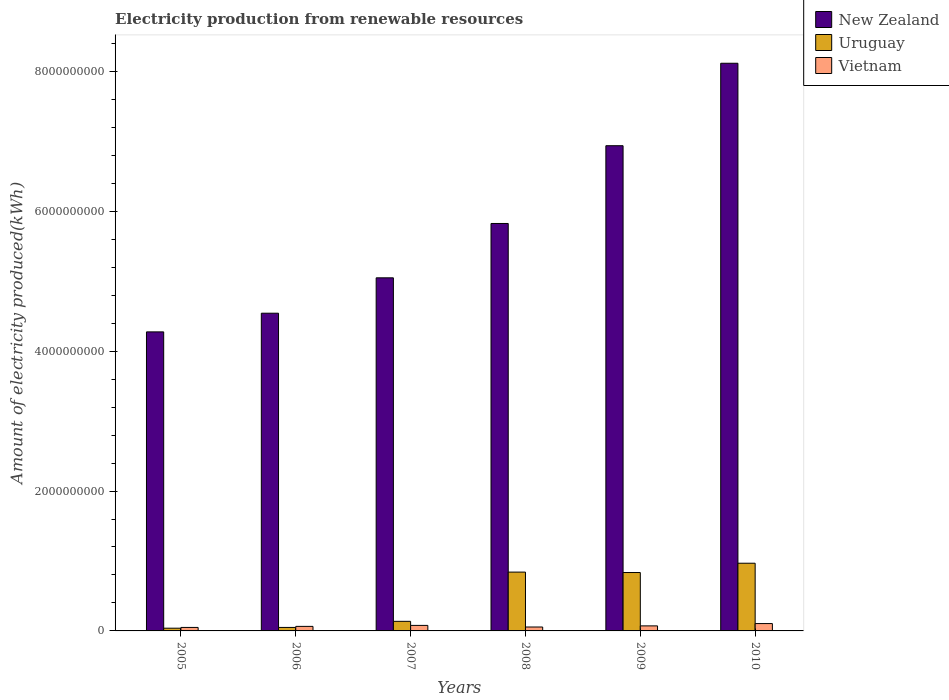How many groups of bars are there?
Make the answer very short. 6. Are the number of bars on each tick of the X-axis equal?
Keep it short and to the point. Yes. What is the label of the 2nd group of bars from the left?
Offer a very short reply. 2006. In how many cases, is the number of bars for a given year not equal to the number of legend labels?
Keep it short and to the point. 0. What is the amount of electricity produced in New Zealand in 2008?
Make the answer very short. 5.83e+09. Across all years, what is the maximum amount of electricity produced in Vietnam?
Keep it short and to the point. 1.05e+08. Across all years, what is the minimum amount of electricity produced in Uruguay?
Ensure brevity in your answer.  3.90e+07. In which year was the amount of electricity produced in New Zealand maximum?
Provide a succinct answer. 2010. In which year was the amount of electricity produced in Vietnam minimum?
Keep it short and to the point. 2005. What is the total amount of electricity produced in Uruguay in the graph?
Ensure brevity in your answer.  2.87e+09. What is the difference between the amount of electricity produced in Vietnam in 2007 and that in 2008?
Ensure brevity in your answer.  2.30e+07. What is the difference between the amount of electricity produced in Uruguay in 2008 and the amount of electricity produced in New Zealand in 2010?
Make the answer very short. -7.28e+09. What is the average amount of electricity produced in Vietnam per year?
Ensure brevity in your answer.  7.12e+07. In the year 2006, what is the difference between the amount of electricity produced in Uruguay and amount of electricity produced in New Zealand?
Keep it short and to the point. -4.49e+09. What is the ratio of the amount of electricity produced in Vietnam in 2007 to that in 2010?
Offer a terse response. 0.75. Is the difference between the amount of electricity produced in Uruguay in 2005 and 2006 greater than the difference between the amount of electricity produced in New Zealand in 2005 and 2006?
Your response must be concise. Yes. What is the difference between the highest and the second highest amount of electricity produced in New Zealand?
Provide a succinct answer. 1.18e+09. What is the difference between the highest and the lowest amount of electricity produced in Vietnam?
Give a very brief answer. 5.50e+07. In how many years, is the amount of electricity produced in New Zealand greater than the average amount of electricity produced in New Zealand taken over all years?
Your answer should be compact. 3. What does the 3rd bar from the left in 2005 represents?
Your response must be concise. Vietnam. What does the 1st bar from the right in 2009 represents?
Keep it short and to the point. Vietnam. Is it the case that in every year, the sum of the amount of electricity produced in Uruguay and amount of electricity produced in New Zealand is greater than the amount of electricity produced in Vietnam?
Provide a short and direct response. Yes. How many bars are there?
Make the answer very short. 18. How many years are there in the graph?
Give a very brief answer. 6. Are the values on the major ticks of Y-axis written in scientific E-notation?
Keep it short and to the point. No. Does the graph contain grids?
Keep it short and to the point. No. Where does the legend appear in the graph?
Ensure brevity in your answer.  Top right. How many legend labels are there?
Your answer should be compact. 3. What is the title of the graph?
Your response must be concise. Electricity production from renewable resources. Does "High income" appear as one of the legend labels in the graph?
Your answer should be very brief. No. What is the label or title of the X-axis?
Keep it short and to the point. Years. What is the label or title of the Y-axis?
Give a very brief answer. Amount of electricity produced(kWh). What is the Amount of electricity produced(kWh) in New Zealand in 2005?
Provide a short and direct response. 4.28e+09. What is the Amount of electricity produced(kWh) in Uruguay in 2005?
Make the answer very short. 3.90e+07. What is the Amount of electricity produced(kWh) in New Zealand in 2006?
Your answer should be very brief. 4.54e+09. What is the Amount of electricity produced(kWh) in Vietnam in 2006?
Give a very brief answer. 6.50e+07. What is the Amount of electricity produced(kWh) of New Zealand in 2007?
Your answer should be very brief. 5.05e+09. What is the Amount of electricity produced(kWh) of Uruguay in 2007?
Provide a succinct answer. 1.37e+08. What is the Amount of electricity produced(kWh) in Vietnam in 2007?
Your response must be concise. 7.90e+07. What is the Amount of electricity produced(kWh) in New Zealand in 2008?
Your answer should be very brief. 5.83e+09. What is the Amount of electricity produced(kWh) in Uruguay in 2008?
Provide a short and direct response. 8.41e+08. What is the Amount of electricity produced(kWh) of Vietnam in 2008?
Your response must be concise. 5.60e+07. What is the Amount of electricity produced(kWh) in New Zealand in 2009?
Offer a very short reply. 6.94e+09. What is the Amount of electricity produced(kWh) in Uruguay in 2009?
Your answer should be compact. 8.35e+08. What is the Amount of electricity produced(kWh) of Vietnam in 2009?
Provide a succinct answer. 7.20e+07. What is the Amount of electricity produced(kWh) of New Zealand in 2010?
Provide a succinct answer. 8.12e+09. What is the Amount of electricity produced(kWh) of Uruguay in 2010?
Ensure brevity in your answer.  9.68e+08. What is the Amount of electricity produced(kWh) of Vietnam in 2010?
Your answer should be compact. 1.05e+08. Across all years, what is the maximum Amount of electricity produced(kWh) of New Zealand?
Your answer should be compact. 8.12e+09. Across all years, what is the maximum Amount of electricity produced(kWh) of Uruguay?
Ensure brevity in your answer.  9.68e+08. Across all years, what is the maximum Amount of electricity produced(kWh) of Vietnam?
Offer a terse response. 1.05e+08. Across all years, what is the minimum Amount of electricity produced(kWh) of New Zealand?
Keep it short and to the point. 4.28e+09. Across all years, what is the minimum Amount of electricity produced(kWh) of Uruguay?
Provide a short and direct response. 3.90e+07. What is the total Amount of electricity produced(kWh) of New Zealand in the graph?
Offer a very short reply. 3.47e+1. What is the total Amount of electricity produced(kWh) of Uruguay in the graph?
Give a very brief answer. 2.87e+09. What is the total Amount of electricity produced(kWh) in Vietnam in the graph?
Offer a very short reply. 4.27e+08. What is the difference between the Amount of electricity produced(kWh) of New Zealand in 2005 and that in 2006?
Your answer should be compact. -2.67e+08. What is the difference between the Amount of electricity produced(kWh) in Uruguay in 2005 and that in 2006?
Provide a succinct answer. -1.10e+07. What is the difference between the Amount of electricity produced(kWh) of Vietnam in 2005 and that in 2006?
Give a very brief answer. -1.50e+07. What is the difference between the Amount of electricity produced(kWh) in New Zealand in 2005 and that in 2007?
Your answer should be compact. -7.73e+08. What is the difference between the Amount of electricity produced(kWh) of Uruguay in 2005 and that in 2007?
Make the answer very short. -9.80e+07. What is the difference between the Amount of electricity produced(kWh) of Vietnam in 2005 and that in 2007?
Your answer should be compact. -2.90e+07. What is the difference between the Amount of electricity produced(kWh) in New Zealand in 2005 and that in 2008?
Your answer should be compact. -1.55e+09. What is the difference between the Amount of electricity produced(kWh) of Uruguay in 2005 and that in 2008?
Make the answer very short. -8.02e+08. What is the difference between the Amount of electricity produced(kWh) of Vietnam in 2005 and that in 2008?
Provide a short and direct response. -6.00e+06. What is the difference between the Amount of electricity produced(kWh) in New Zealand in 2005 and that in 2009?
Your answer should be very brief. -2.66e+09. What is the difference between the Amount of electricity produced(kWh) in Uruguay in 2005 and that in 2009?
Provide a short and direct response. -7.96e+08. What is the difference between the Amount of electricity produced(kWh) in Vietnam in 2005 and that in 2009?
Provide a short and direct response. -2.20e+07. What is the difference between the Amount of electricity produced(kWh) in New Zealand in 2005 and that in 2010?
Make the answer very short. -3.84e+09. What is the difference between the Amount of electricity produced(kWh) in Uruguay in 2005 and that in 2010?
Make the answer very short. -9.29e+08. What is the difference between the Amount of electricity produced(kWh) of Vietnam in 2005 and that in 2010?
Ensure brevity in your answer.  -5.50e+07. What is the difference between the Amount of electricity produced(kWh) in New Zealand in 2006 and that in 2007?
Your response must be concise. -5.06e+08. What is the difference between the Amount of electricity produced(kWh) of Uruguay in 2006 and that in 2007?
Keep it short and to the point. -8.70e+07. What is the difference between the Amount of electricity produced(kWh) in Vietnam in 2006 and that in 2007?
Your response must be concise. -1.40e+07. What is the difference between the Amount of electricity produced(kWh) in New Zealand in 2006 and that in 2008?
Your answer should be compact. -1.28e+09. What is the difference between the Amount of electricity produced(kWh) in Uruguay in 2006 and that in 2008?
Provide a short and direct response. -7.91e+08. What is the difference between the Amount of electricity produced(kWh) of Vietnam in 2006 and that in 2008?
Your answer should be compact. 9.00e+06. What is the difference between the Amount of electricity produced(kWh) in New Zealand in 2006 and that in 2009?
Provide a succinct answer. -2.40e+09. What is the difference between the Amount of electricity produced(kWh) in Uruguay in 2006 and that in 2009?
Your answer should be very brief. -7.85e+08. What is the difference between the Amount of electricity produced(kWh) in Vietnam in 2006 and that in 2009?
Your response must be concise. -7.00e+06. What is the difference between the Amount of electricity produced(kWh) in New Zealand in 2006 and that in 2010?
Your response must be concise. -3.57e+09. What is the difference between the Amount of electricity produced(kWh) of Uruguay in 2006 and that in 2010?
Provide a short and direct response. -9.18e+08. What is the difference between the Amount of electricity produced(kWh) in Vietnam in 2006 and that in 2010?
Your answer should be very brief. -4.00e+07. What is the difference between the Amount of electricity produced(kWh) of New Zealand in 2007 and that in 2008?
Offer a terse response. -7.77e+08. What is the difference between the Amount of electricity produced(kWh) of Uruguay in 2007 and that in 2008?
Give a very brief answer. -7.04e+08. What is the difference between the Amount of electricity produced(kWh) in Vietnam in 2007 and that in 2008?
Your response must be concise. 2.30e+07. What is the difference between the Amount of electricity produced(kWh) of New Zealand in 2007 and that in 2009?
Offer a terse response. -1.89e+09. What is the difference between the Amount of electricity produced(kWh) of Uruguay in 2007 and that in 2009?
Your response must be concise. -6.98e+08. What is the difference between the Amount of electricity produced(kWh) in Vietnam in 2007 and that in 2009?
Your response must be concise. 7.00e+06. What is the difference between the Amount of electricity produced(kWh) in New Zealand in 2007 and that in 2010?
Provide a short and direct response. -3.07e+09. What is the difference between the Amount of electricity produced(kWh) of Uruguay in 2007 and that in 2010?
Ensure brevity in your answer.  -8.31e+08. What is the difference between the Amount of electricity produced(kWh) in Vietnam in 2007 and that in 2010?
Provide a succinct answer. -2.60e+07. What is the difference between the Amount of electricity produced(kWh) of New Zealand in 2008 and that in 2009?
Ensure brevity in your answer.  -1.11e+09. What is the difference between the Amount of electricity produced(kWh) of Vietnam in 2008 and that in 2009?
Offer a very short reply. -1.60e+07. What is the difference between the Amount of electricity produced(kWh) in New Zealand in 2008 and that in 2010?
Give a very brief answer. -2.29e+09. What is the difference between the Amount of electricity produced(kWh) in Uruguay in 2008 and that in 2010?
Provide a short and direct response. -1.27e+08. What is the difference between the Amount of electricity produced(kWh) of Vietnam in 2008 and that in 2010?
Your answer should be very brief. -4.90e+07. What is the difference between the Amount of electricity produced(kWh) in New Zealand in 2009 and that in 2010?
Give a very brief answer. -1.18e+09. What is the difference between the Amount of electricity produced(kWh) in Uruguay in 2009 and that in 2010?
Ensure brevity in your answer.  -1.33e+08. What is the difference between the Amount of electricity produced(kWh) in Vietnam in 2009 and that in 2010?
Give a very brief answer. -3.30e+07. What is the difference between the Amount of electricity produced(kWh) of New Zealand in 2005 and the Amount of electricity produced(kWh) of Uruguay in 2006?
Your answer should be very brief. 4.23e+09. What is the difference between the Amount of electricity produced(kWh) in New Zealand in 2005 and the Amount of electricity produced(kWh) in Vietnam in 2006?
Provide a succinct answer. 4.21e+09. What is the difference between the Amount of electricity produced(kWh) of Uruguay in 2005 and the Amount of electricity produced(kWh) of Vietnam in 2006?
Your answer should be very brief. -2.60e+07. What is the difference between the Amount of electricity produced(kWh) of New Zealand in 2005 and the Amount of electricity produced(kWh) of Uruguay in 2007?
Offer a terse response. 4.14e+09. What is the difference between the Amount of electricity produced(kWh) of New Zealand in 2005 and the Amount of electricity produced(kWh) of Vietnam in 2007?
Your answer should be compact. 4.20e+09. What is the difference between the Amount of electricity produced(kWh) of Uruguay in 2005 and the Amount of electricity produced(kWh) of Vietnam in 2007?
Keep it short and to the point. -4.00e+07. What is the difference between the Amount of electricity produced(kWh) of New Zealand in 2005 and the Amount of electricity produced(kWh) of Uruguay in 2008?
Your answer should be very brief. 3.44e+09. What is the difference between the Amount of electricity produced(kWh) of New Zealand in 2005 and the Amount of electricity produced(kWh) of Vietnam in 2008?
Make the answer very short. 4.22e+09. What is the difference between the Amount of electricity produced(kWh) in Uruguay in 2005 and the Amount of electricity produced(kWh) in Vietnam in 2008?
Your answer should be compact. -1.70e+07. What is the difference between the Amount of electricity produced(kWh) in New Zealand in 2005 and the Amount of electricity produced(kWh) in Uruguay in 2009?
Keep it short and to the point. 3.44e+09. What is the difference between the Amount of electricity produced(kWh) of New Zealand in 2005 and the Amount of electricity produced(kWh) of Vietnam in 2009?
Ensure brevity in your answer.  4.20e+09. What is the difference between the Amount of electricity produced(kWh) in Uruguay in 2005 and the Amount of electricity produced(kWh) in Vietnam in 2009?
Your answer should be compact. -3.30e+07. What is the difference between the Amount of electricity produced(kWh) of New Zealand in 2005 and the Amount of electricity produced(kWh) of Uruguay in 2010?
Provide a succinct answer. 3.31e+09. What is the difference between the Amount of electricity produced(kWh) in New Zealand in 2005 and the Amount of electricity produced(kWh) in Vietnam in 2010?
Offer a terse response. 4.17e+09. What is the difference between the Amount of electricity produced(kWh) of Uruguay in 2005 and the Amount of electricity produced(kWh) of Vietnam in 2010?
Provide a succinct answer. -6.60e+07. What is the difference between the Amount of electricity produced(kWh) of New Zealand in 2006 and the Amount of electricity produced(kWh) of Uruguay in 2007?
Provide a succinct answer. 4.41e+09. What is the difference between the Amount of electricity produced(kWh) of New Zealand in 2006 and the Amount of electricity produced(kWh) of Vietnam in 2007?
Your response must be concise. 4.46e+09. What is the difference between the Amount of electricity produced(kWh) of Uruguay in 2006 and the Amount of electricity produced(kWh) of Vietnam in 2007?
Provide a short and direct response. -2.90e+07. What is the difference between the Amount of electricity produced(kWh) in New Zealand in 2006 and the Amount of electricity produced(kWh) in Uruguay in 2008?
Keep it short and to the point. 3.70e+09. What is the difference between the Amount of electricity produced(kWh) of New Zealand in 2006 and the Amount of electricity produced(kWh) of Vietnam in 2008?
Your answer should be very brief. 4.49e+09. What is the difference between the Amount of electricity produced(kWh) of Uruguay in 2006 and the Amount of electricity produced(kWh) of Vietnam in 2008?
Give a very brief answer. -6.00e+06. What is the difference between the Amount of electricity produced(kWh) of New Zealand in 2006 and the Amount of electricity produced(kWh) of Uruguay in 2009?
Offer a terse response. 3.71e+09. What is the difference between the Amount of electricity produced(kWh) in New Zealand in 2006 and the Amount of electricity produced(kWh) in Vietnam in 2009?
Offer a terse response. 4.47e+09. What is the difference between the Amount of electricity produced(kWh) of Uruguay in 2006 and the Amount of electricity produced(kWh) of Vietnam in 2009?
Your answer should be very brief. -2.20e+07. What is the difference between the Amount of electricity produced(kWh) of New Zealand in 2006 and the Amount of electricity produced(kWh) of Uruguay in 2010?
Your response must be concise. 3.58e+09. What is the difference between the Amount of electricity produced(kWh) in New Zealand in 2006 and the Amount of electricity produced(kWh) in Vietnam in 2010?
Your response must be concise. 4.44e+09. What is the difference between the Amount of electricity produced(kWh) in Uruguay in 2006 and the Amount of electricity produced(kWh) in Vietnam in 2010?
Keep it short and to the point. -5.50e+07. What is the difference between the Amount of electricity produced(kWh) of New Zealand in 2007 and the Amount of electricity produced(kWh) of Uruguay in 2008?
Your response must be concise. 4.21e+09. What is the difference between the Amount of electricity produced(kWh) of New Zealand in 2007 and the Amount of electricity produced(kWh) of Vietnam in 2008?
Your answer should be compact. 4.99e+09. What is the difference between the Amount of electricity produced(kWh) of Uruguay in 2007 and the Amount of electricity produced(kWh) of Vietnam in 2008?
Offer a very short reply. 8.10e+07. What is the difference between the Amount of electricity produced(kWh) of New Zealand in 2007 and the Amount of electricity produced(kWh) of Uruguay in 2009?
Offer a terse response. 4.21e+09. What is the difference between the Amount of electricity produced(kWh) in New Zealand in 2007 and the Amount of electricity produced(kWh) in Vietnam in 2009?
Ensure brevity in your answer.  4.98e+09. What is the difference between the Amount of electricity produced(kWh) of Uruguay in 2007 and the Amount of electricity produced(kWh) of Vietnam in 2009?
Provide a short and direct response. 6.50e+07. What is the difference between the Amount of electricity produced(kWh) in New Zealand in 2007 and the Amount of electricity produced(kWh) in Uruguay in 2010?
Your response must be concise. 4.08e+09. What is the difference between the Amount of electricity produced(kWh) of New Zealand in 2007 and the Amount of electricity produced(kWh) of Vietnam in 2010?
Make the answer very short. 4.94e+09. What is the difference between the Amount of electricity produced(kWh) of Uruguay in 2007 and the Amount of electricity produced(kWh) of Vietnam in 2010?
Your answer should be compact. 3.20e+07. What is the difference between the Amount of electricity produced(kWh) of New Zealand in 2008 and the Amount of electricity produced(kWh) of Uruguay in 2009?
Provide a succinct answer. 4.99e+09. What is the difference between the Amount of electricity produced(kWh) in New Zealand in 2008 and the Amount of electricity produced(kWh) in Vietnam in 2009?
Offer a terse response. 5.75e+09. What is the difference between the Amount of electricity produced(kWh) in Uruguay in 2008 and the Amount of electricity produced(kWh) in Vietnam in 2009?
Keep it short and to the point. 7.69e+08. What is the difference between the Amount of electricity produced(kWh) in New Zealand in 2008 and the Amount of electricity produced(kWh) in Uruguay in 2010?
Make the answer very short. 4.86e+09. What is the difference between the Amount of electricity produced(kWh) in New Zealand in 2008 and the Amount of electricity produced(kWh) in Vietnam in 2010?
Make the answer very short. 5.72e+09. What is the difference between the Amount of electricity produced(kWh) in Uruguay in 2008 and the Amount of electricity produced(kWh) in Vietnam in 2010?
Give a very brief answer. 7.36e+08. What is the difference between the Amount of electricity produced(kWh) in New Zealand in 2009 and the Amount of electricity produced(kWh) in Uruguay in 2010?
Offer a very short reply. 5.97e+09. What is the difference between the Amount of electricity produced(kWh) in New Zealand in 2009 and the Amount of electricity produced(kWh) in Vietnam in 2010?
Provide a short and direct response. 6.83e+09. What is the difference between the Amount of electricity produced(kWh) in Uruguay in 2009 and the Amount of electricity produced(kWh) in Vietnam in 2010?
Provide a short and direct response. 7.30e+08. What is the average Amount of electricity produced(kWh) of New Zealand per year?
Provide a short and direct response. 5.79e+09. What is the average Amount of electricity produced(kWh) of Uruguay per year?
Provide a short and direct response. 4.78e+08. What is the average Amount of electricity produced(kWh) in Vietnam per year?
Keep it short and to the point. 7.12e+07. In the year 2005, what is the difference between the Amount of electricity produced(kWh) in New Zealand and Amount of electricity produced(kWh) in Uruguay?
Offer a terse response. 4.24e+09. In the year 2005, what is the difference between the Amount of electricity produced(kWh) in New Zealand and Amount of electricity produced(kWh) in Vietnam?
Keep it short and to the point. 4.23e+09. In the year 2005, what is the difference between the Amount of electricity produced(kWh) in Uruguay and Amount of electricity produced(kWh) in Vietnam?
Your answer should be very brief. -1.10e+07. In the year 2006, what is the difference between the Amount of electricity produced(kWh) of New Zealand and Amount of electricity produced(kWh) of Uruguay?
Make the answer very short. 4.49e+09. In the year 2006, what is the difference between the Amount of electricity produced(kWh) of New Zealand and Amount of electricity produced(kWh) of Vietnam?
Ensure brevity in your answer.  4.48e+09. In the year 2006, what is the difference between the Amount of electricity produced(kWh) of Uruguay and Amount of electricity produced(kWh) of Vietnam?
Offer a very short reply. -1.50e+07. In the year 2007, what is the difference between the Amount of electricity produced(kWh) in New Zealand and Amount of electricity produced(kWh) in Uruguay?
Give a very brief answer. 4.91e+09. In the year 2007, what is the difference between the Amount of electricity produced(kWh) in New Zealand and Amount of electricity produced(kWh) in Vietnam?
Offer a terse response. 4.97e+09. In the year 2007, what is the difference between the Amount of electricity produced(kWh) of Uruguay and Amount of electricity produced(kWh) of Vietnam?
Offer a terse response. 5.80e+07. In the year 2008, what is the difference between the Amount of electricity produced(kWh) in New Zealand and Amount of electricity produced(kWh) in Uruguay?
Your answer should be compact. 4.98e+09. In the year 2008, what is the difference between the Amount of electricity produced(kWh) in New Zealand and Amount of electricity produced(kWh) in Vietnam?
Your response must be concise. 5.77e+09. In the year 2008, what is the difference between the Amount of electricity produced(kWh) in Uruguay and Amount of electricity produced(kWh) in Vietnam?
Your answer should be compact. 7.85e+08. In the year 2009, what is the difference between the Amount of electricity produced(kWh) in New Zealand and Amount of electricity produced(kWh) in Uruguay?
Ensure brevity in your answer.  6.10e+09. In the year 2009, what is the difference between the Amount of electricity produced(kWh) of New Zealand and Amount of electricity produced(kWh) of Vietnam?
Ensure brevity in your answer.  6.87e+09. In the year 2009, what is the difference between the Amount of electricity produced(kWh) in Uruguay and Amount of electricity produced(kWh) in Vietnam?
Provide a succinct answer. 7.63e+08. In the year 2010, what is the difference between the Amount of electricity produced(kWh) of New Zealand and Amount of electricity produced(kWh) of Uruguay?
Keep it short and to the point. 7.15e+09. In the year 2010, what is the difference between the Amount of electricity produced(kWh) of New Zealand and Amount of electricity produced(kWh) of Vietnam?
Offer a very short reply. 8.01e+09. In the year 2010, what is the difference between the Amount of electricity produced(kWh) in Uruguay and Amount of electricity produced(kWh) in Vietnam?
Your answer should be compact. 8.63e+08. What is the ratio of the Amount of electricity produced(kWh) of Uruguay in 2005 to that in 2006?
Your response must be concise. 0.78. What is the ratio of the Amount of electricity produced(kWh) of Vietnam in 2005 to that in 2006?
Your answer should be compact. 0.77. What is the ratio of the Amount of electricity produced(kWh) in New Zealand in 2005 to that in 2007?
Provide a succinct answer. 0.85. What is the ratio of the Amount of electricity produced(kWh) in Uruguay in 2005 to that in 2007?
Offer a very short reply. 0.28. What is the ratio of the Amount of electricity produced(kWh) of Vietnam in 2005 to that in 2007?
Your answer should be very brief. 0.63. What is the ratio of the Amount of electricity produced(kWh) in New Zealand in 2005 to that in 2008?
Make the answer very short. 0.73. What is the ratio of the Amount of electricity produced(kWh) of Uruguay in 2005 to that in 2008?
Provide a succinct answer. 0.05. What is the ratio of the Amount of electricity produced(kWh) of Vietnam in 2005 to that in 2008?
Your answer should be very brief. 0.89. What is the ratio of the Amount of electricity produced(kWh) in New Zealand in 2005 to that in 2009?
Give a very brief answer. 0.62. What is the ratio of the Amount of electricity produced(kWh) in Uruguay in 2005 to that in 2009?
Offer a terse response. 0.05. What is the ratio of the Amount of electricity produced(kWh) in Vietnam in 2005 to that in 2009?
Keep it short and to the point. 0.69. What is the ratio of the Amount of electricity produced(kWh) in New Zealand in 2005 to that in 2010?
Your response must be concise. 0.53. What is the ratio of the Amount of electricity produced(kWh) in Uruguay in 2005 to that in 2010?
Keep it short and to the point. 0.04. What is the ratio of the Amount of electricity produced(kWh) in Vietnam in 2005 to that in 2010?
Keep it short and to the point. 0.48. What is the ratio of the Amount of electricity produced(kWh) in New Zealand in 2006 to that in 2007?
Keep it short and to the point. 0.9. What is the ratio of the Amount of electricity produced(kWh) in Uruguay in 2006 to that in 2007?
Your response must be concise. 0.36. What is the ratio of the Amount of electricity produced(kWh) of Vietnam in 2006 to that in 2007?
Make the answer very short. 0.82. What is the ratio of the Amount of electricity produced(kWh) in New Zealand in 2006 to that in 2008?
Provide a succinct answer. 0.78. What is the ratio of the Amount of electricity produced(kWh) of Uruguay in 2006 to that in 2008?
Give a very brief answer. 0.06. What is the ratio of the Amount of electricity produced(kWh) of Vietnam in 2006 to that in 2008?
Make the answer very short. 1.16. What is the ratio of the Amount of electricity produced(kWh) in New Zealand in 2006 to that in 2009?
Provide a succinct answer. 0.65. What is the ratio of the Amount of electricity produced(kWh) in Uruguay in 2006 to that in 2009?
Offer a very short reply. 0.06. What is the ratio of the Amount of electricity produced(kWh) in Vietnam in 2006 to that in 2009?
Keep it short and to the point. 0.9. What is the ratio of the Amount of electricity produced(kWh) in New Zealand in 2006 to that in 2010?
Offer a terse response. 0.56. What is the ratio of the Amount of electricity produced(kWh) in Uruguay in 2006 to that in 2010?
Provide a succinct answer. 0.05. What is the ratio of the Amount of electricity produced(kWh) of Vietnam in 2006 to that in 2010?
Offer a terse response. 0.62. What is the ratio of the Amount of electricity produced(kWh) in New Zealand in 2007 to that in 2008?
Your answer should be compact. 0.87. What is the ratio of the Amount of electricity produced(kWh) of Uruguay in 2007 to that in 2008?
Your response must be concise. 0.16. What is the ratio of the Amount of electricity produced(kWh) of Vietnam in 2007 to that in 2008?
Offer a very short reply. 1.41. What is the ratio of the Amount of electricity produced(kWh) in New Zealand in 2007 to that in 2009?
Give a very brief answer. 0.73. What is the ratio of the Amount of electricity produced(kWh) of Uruguay in 2007 to that in 2009?
Provide a short and direct response. 0.16. What is the ratio of the Amount of electricity produced(kWh) of Vietnam in 2007 to that in 2009?
Keep it short and to the point. 1.1. What is the ratio of the Amount of electricity produced(kWh) in New Zealand in 2007 to that in 2010?
Your response must be concise. 0.62. What is the ratio of the Amount of electricity produced(kWh) in Uruguay in 2007 to that in 2010?
Provide a succinct answer. 0.14. What is the ratio of the Amount of electricity produced(kWh) in Vietnam in 2007 to that in 2010?
Offer a very short reply. 0.75. What is the ratio of the Amount of electricity produced(kWh) of New Zealand in 2008 to that in 2009?
Ensure brevity in your answer.  0.84. What is the ratio of the Amount of electricity produced(kWh) in Uruguay in 2008 to that in 2009?
Keep it short and to the point. 1.01. What is the ratio of the Amount of electricity produced(kWh) in Vietnam in 2008 to that in 2009?
Ensure brevity in your answer.  0.78. What is the ratio of the Amount of electricity produced(kWh) in New Zealand in 2008 to that in 2010?
Ensure brevity in your answer.  0.72. What is the ratio of the Amount of electricity produced(kWh) in Uruguay in 2008 to that in 2010?
Ensure brevity in your answer.  0.87. What is the ratio of the Amount of electricity produced(kWh) of Vietnam in 2008 to that in 2010?
Your answer should be compact. 0.53. What is the ratio of the Amount of electricity produced(kWh) of New Zealand in 2009 to that in 2010?
Offer a terse response. 0.85. What is the ratio of the Amount of electricity produced(kWh) of Uruguay in 2009 to that in 2010?
Make the answer very short. 0.86. What is the ratio of the Amount of electricity produced(kWh) of Vietnam in 2009 to that in 2010?
Ensure brevity in your answer.  0.69. What is the difference between the highest and the second highest Amount of electricity produced(kWh) of New Zealand?
Your answer should be compact. 1.18e+09. What is the difference between the highest and the second highest Amount of electricity produced(kWh) in Uruguay?
Offer a terse response. 1.27e+08. What is the difference between the highest and the second highest Amount of electricity produced(kWh) in Vietnam?
Ensure brevity in your answer.  2.60e+07. What is the difference between the highest and the lowest Amount of electricity produced(kWh) in New Zealand?
Your response must be concise. 3.84e+09. What is the difference between the highest and the lowest Amount of electricity produced(kWh) in Uruguay?
Your response must be concise. 9.29e+08. What is the difference between the highest and the lowest Amount of electricity produced(kWh) of Vietnam?
Your response must be concise. 5.50e+07. 